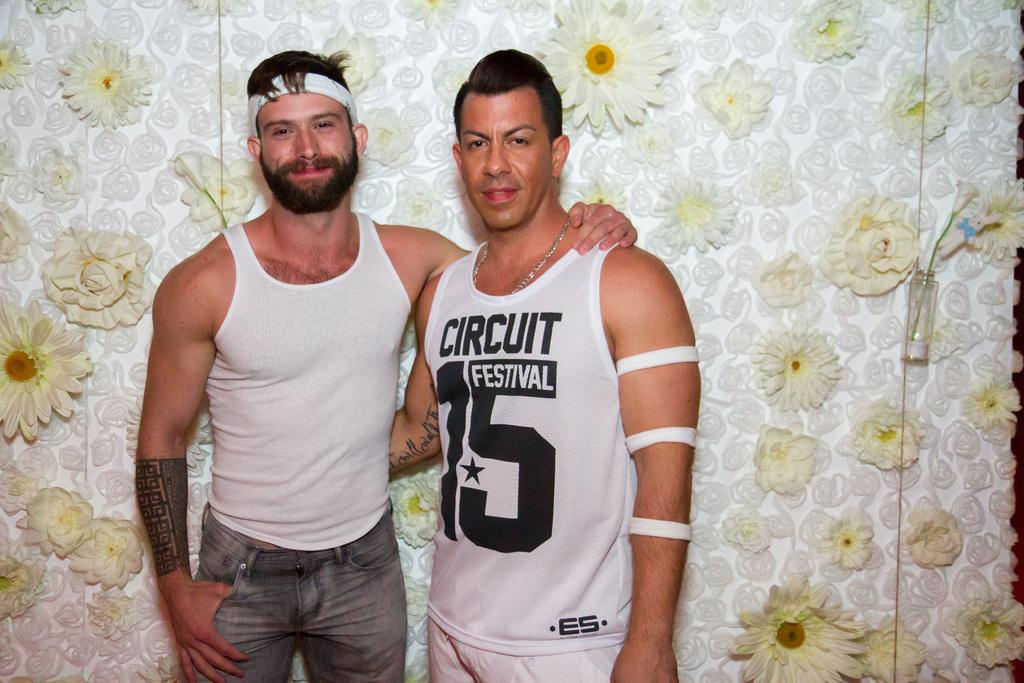What festival are they planning to attend?
Offer a very short reply. Circuit festival. What is the number on the mans shirt to the right?
Provide a short and direct response. 15. 